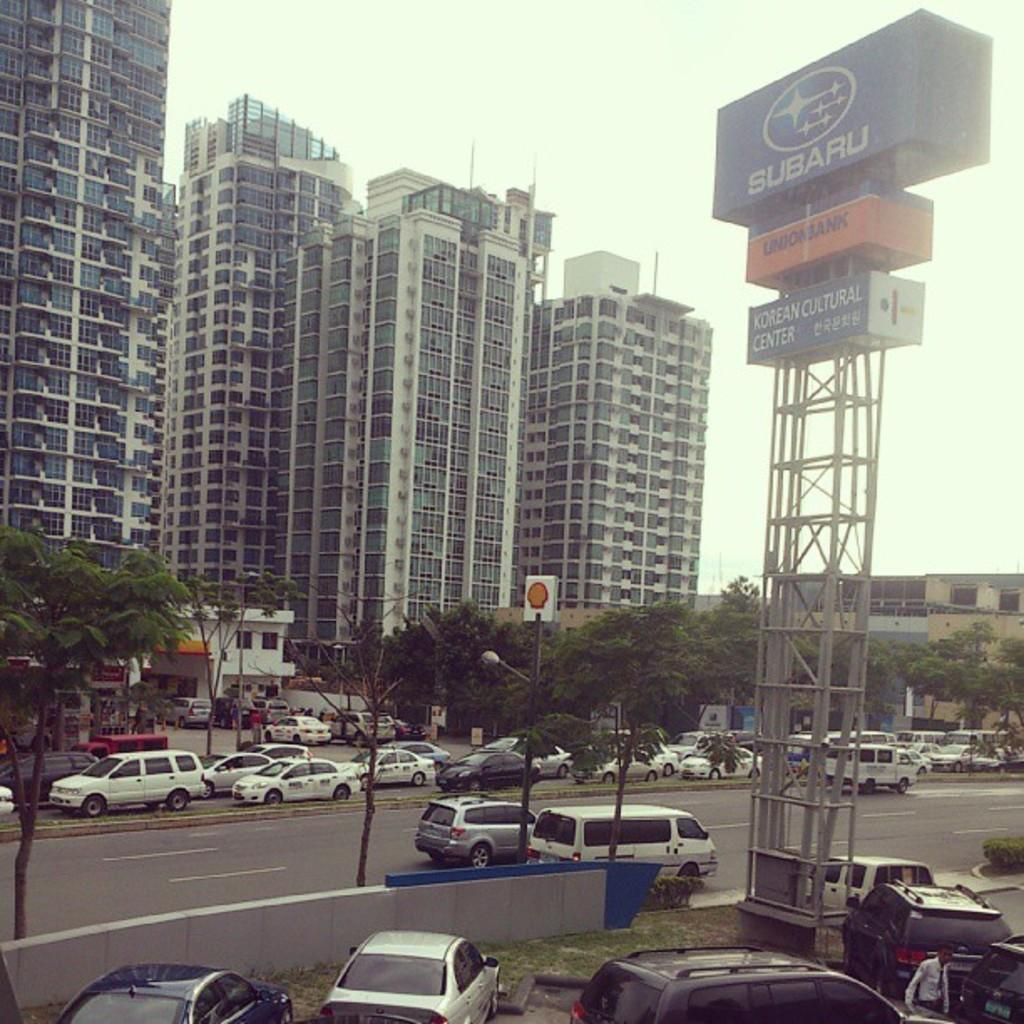What type of structures can be seen in the image? There are buildings in the image. What other natural elements are present in the image? There are trees in the image. What type of transportation is visible in the image? There are cars on the road and parked cars in the image. What might be used for displaying information or advertisements in the image? There are boards with text in the image. What is visible in the background of the image? The sky is visible in the image. Can you tell me how many grandfathers are sitting on the dock in the image? There is no dock or grandfather present in the image. What type of card is being used to play a game in the image? There is no card game present in the image. 